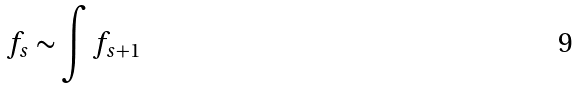Convert formula to latex. <formula><loc_0><loc_0><loc_500><loc_500>f _ { s } \sim \int f _ { s + 1 }</formula> 